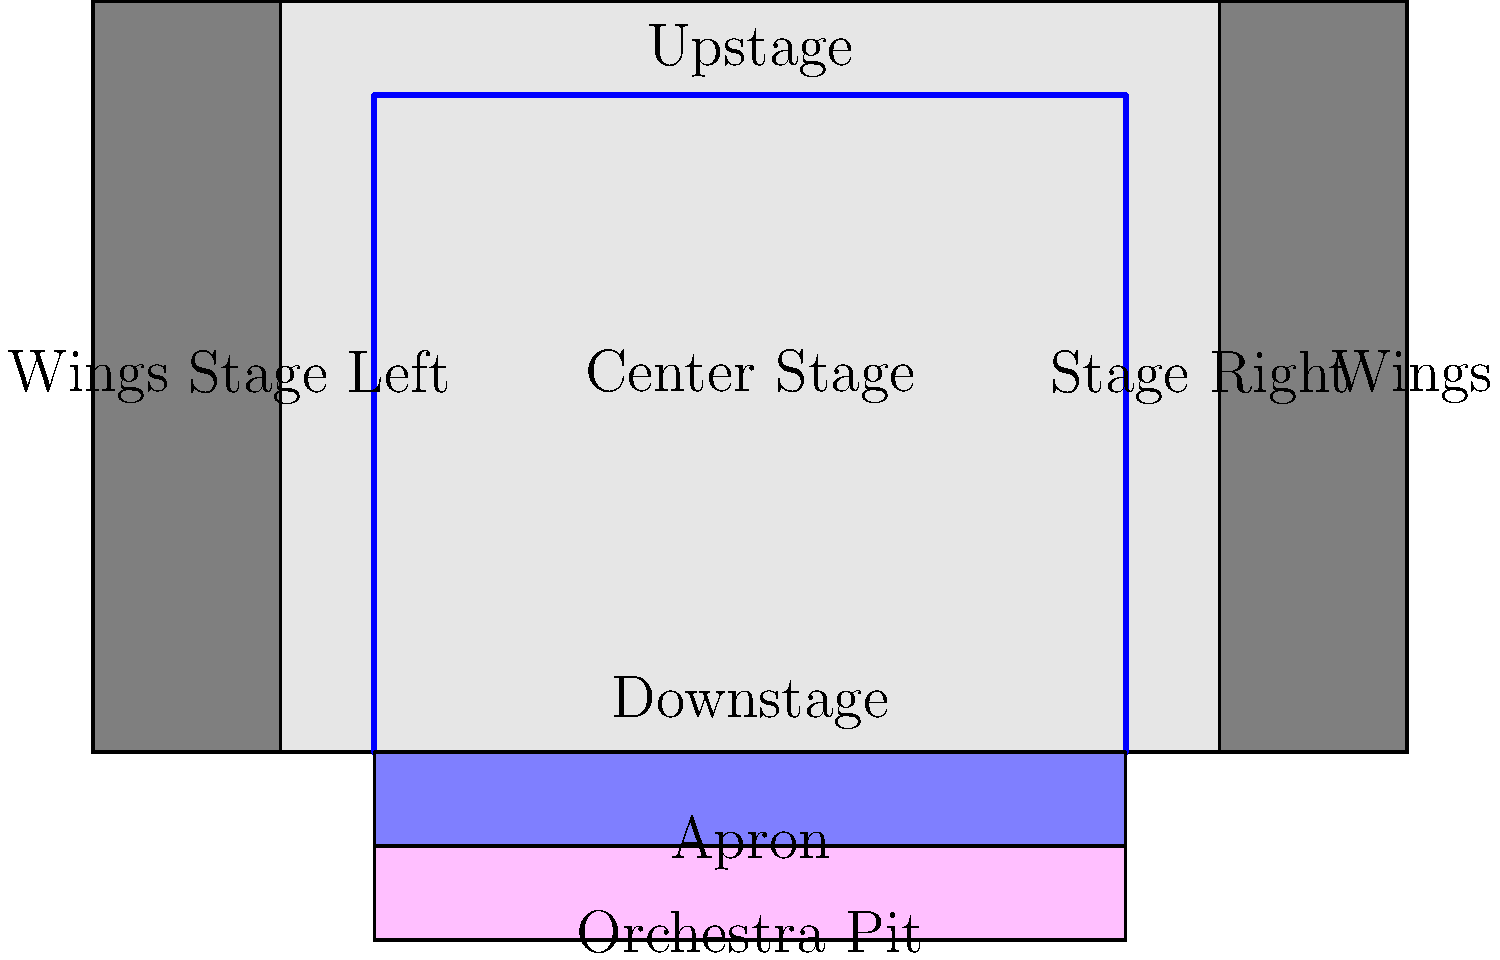In a typical theater stage layout, what is the name of the area in front of the main stage that extends towards the audience and is often shaped like a half-circle or rectangle? To answer this question, let's break down the key elements of a typical theater stage:

1. The main stage is the central performance area where most of the action takes place.

2. The proscenium arch is the frame that separates the stage from the auditorium.

3. Upstage refers to the back of the stage, farthest from the audience.

4. Downstage is the front part of the stage, closest to the audience.

5. Stage left and stage right are from the actor's perspective facing the audience.

6. The wings are the areas on either side of the stage, hidden from the audience's view.

7. The orchestra pit is located in front of and slightly below the main stage, where musicians perform during musical productions.

8. The apron is the area in front of the main stage that extends towards the audience. It is typically shaped like a half-circle or rectangle and is located between the main stage and the orchestra pit.

The area in question, which extends in front of the main stage towards the audience, is called the apron. It serves as an additional performance space and can be used for various purposes, such as soliloquies, intimate scenes, or to bring actors closer to the audience.
Answer: Apron 